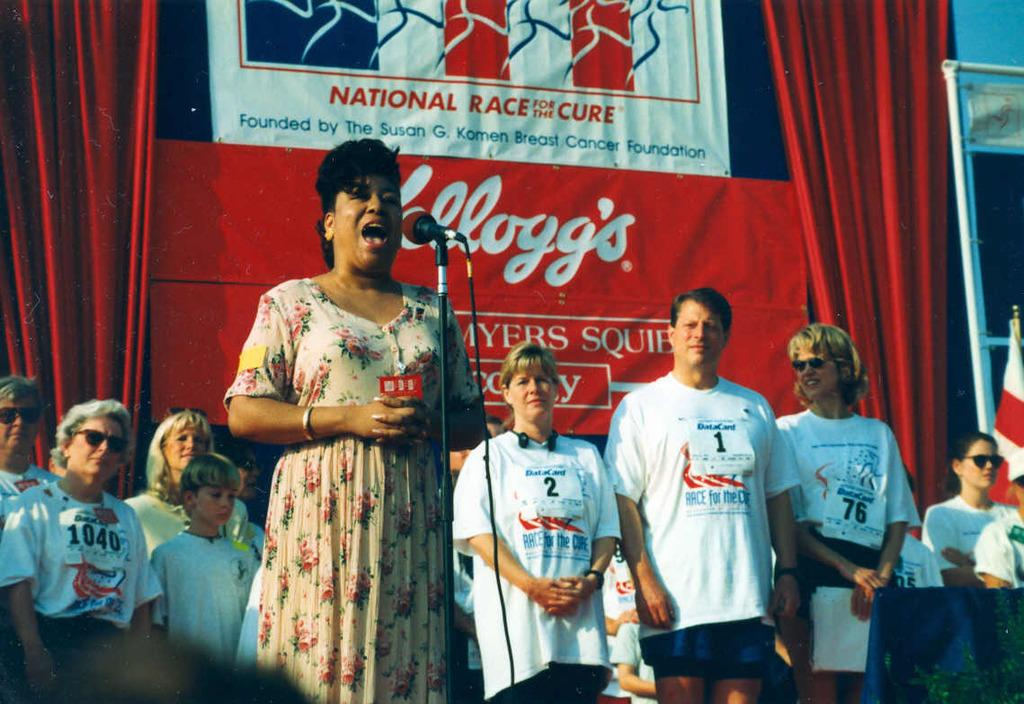Provide a one-sentence caption for the provided image. A woman singing at the National Race for the Cure. 